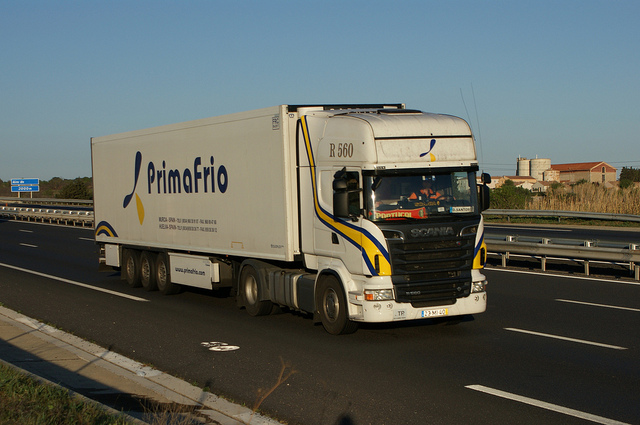<image>What is the brand of the truck? I am not sure what the brand of the truck is. It could be Scania, Primafrio, or Toyota. Is this area rural? I am not sure if the area is rural. What is this truck transporting? It is unclear what the truck is transporting. It could be cargo, goods, food, primafrio, refrigerated goods, or furniture. What is the brand of the truck? I am not sure what is the brand of the truck. It can be seen as 'scania' or 'primafrio'. Is this area rural? I am not sure if this area is rural. It can be both rural and non-rural. What is this truck transporting? I don't know what this truck is transporting. It can be transporting cargo, goods, primafrio, food, refrigerated goods, or furniture. 